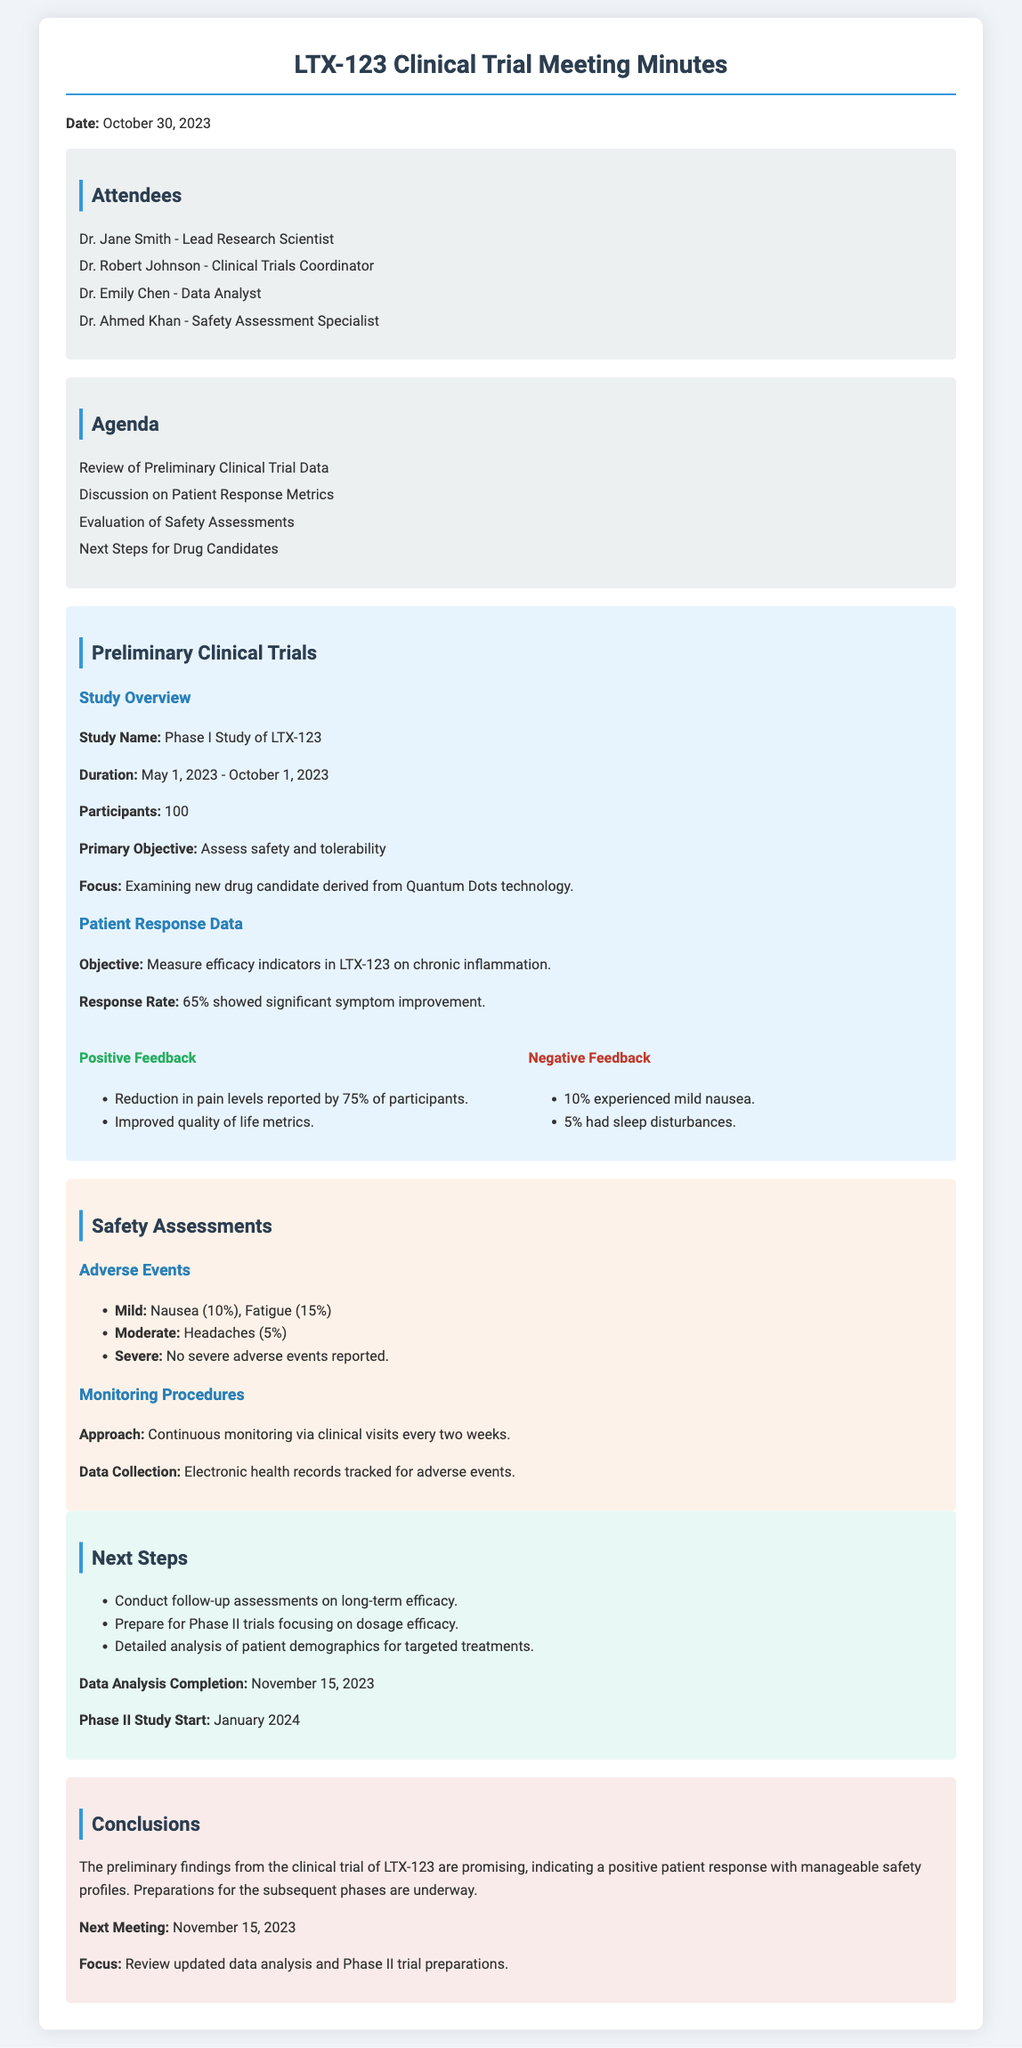What is the study name? The study name is stated clearly in the document under the Study Overview section.
Answer: Phase I Study of LTX-123 What was the response rate? The response rate is mentioned under the Patient Response Data section, highlighting the percentage of participants who showed improvement.
Answer: 65% How long did the study last? The duration of the study is noted in the Study Overview section, detailing the start and end dates.
Answer: May 1, 2023 - October 1, 2023 How many participants were involved in the trial? The number of participants is specified in the Study Overview section, which relates to the study's scale.
Answer: 100 What percentage of participants experienced mild nausea? The document provides specific percentages of adverse events under the Safety Assessments section.
Answer: 10% What were the two mild adverse events reported? The mild adverse events are listed in the Safety Assessments section, providing insights into patient responses to the drug.
Answer: Nausea, Fatigue When is the next meeting scheduled? The date for the next meeting is mentioned in the Conclusions section, indicating follow-up discussions.
Answer: November 15, 2023 What is the primary objective of the study? The primary objective is clearly stated in the Study Overview section, focusing on safety and tolerability assessments.
Answer: Assess safety and tolerability What are the next steps for the drug candidates? The document outlines specific next steps in the Next Steps section, detailing future actions following the trial.
Answer: Conduct follow-up assessments on long-term efficacy 